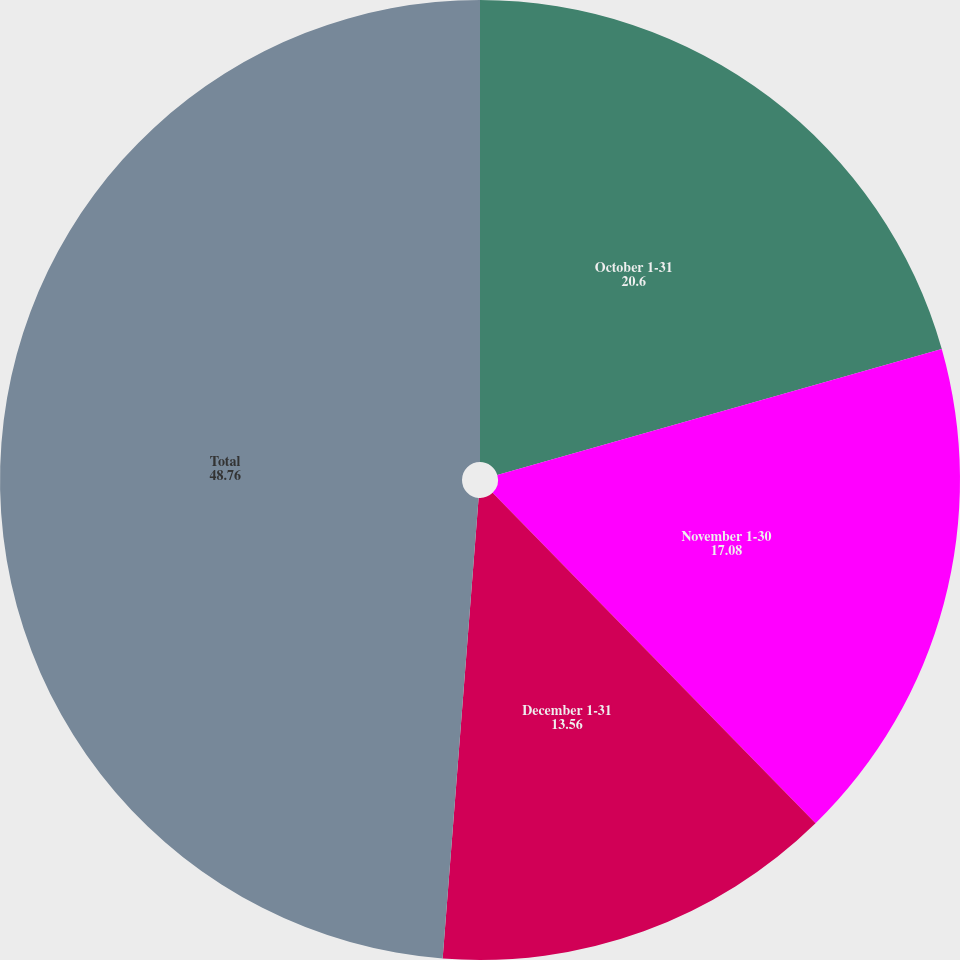<chart> <loc_0><loc_0><loc_500><loc_500><pie_chart><fcel>October 1-31<fcel>November 1-30<fcel>December 1-31<fcel>Total<nl><fcel>20.6%<fcel>17.08%<fcel>13.56%<fcel>48.76%<nl></chart> 